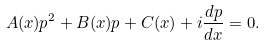<formula> <loc_0><loc_0><loc_500><loc_500>A ( x ) p ^ { 2 } + B ( x ) p + C ( x ) + i \frac { d p } { d x } = 0 .</formula> 